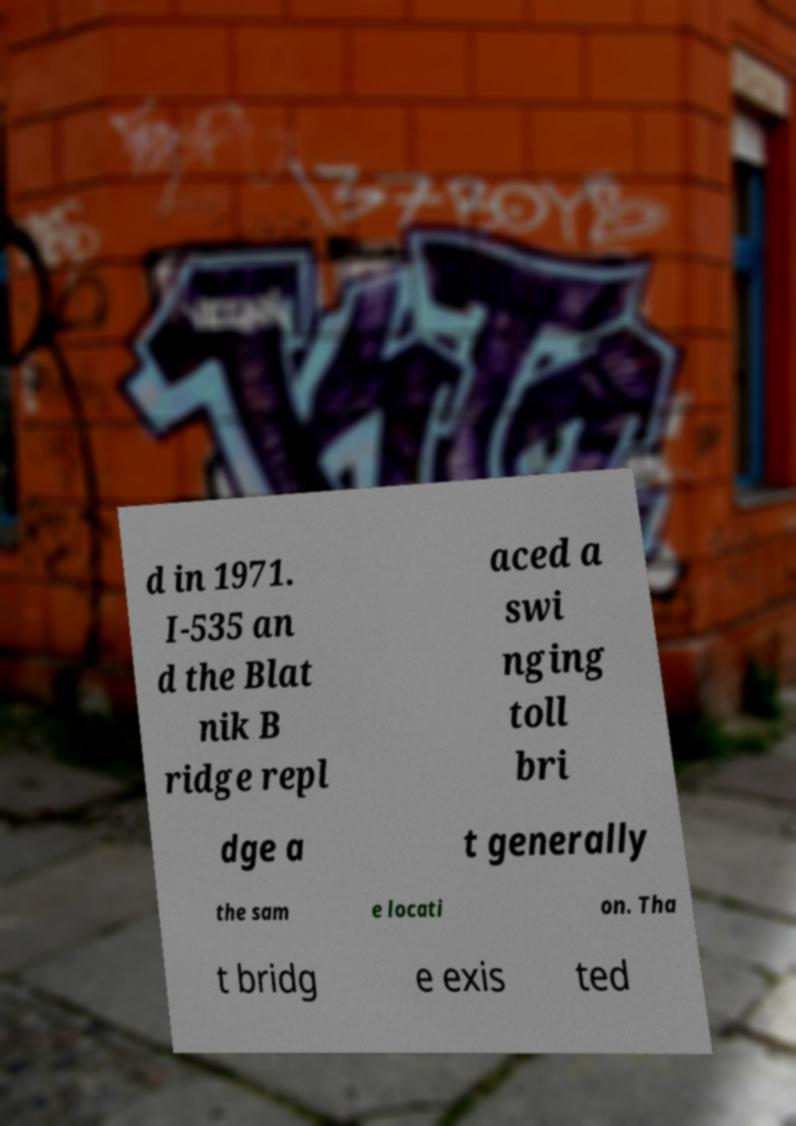Can you read and provide the text displayed in the image?This photo seems to have some interesting text. Can you extract and type it out for me? d in 1971. I-535 an d the Blat nik B ridge repl aced a swi nging toll bri dge a t generally the sam e locati on. Tha t bridg e exis ted 